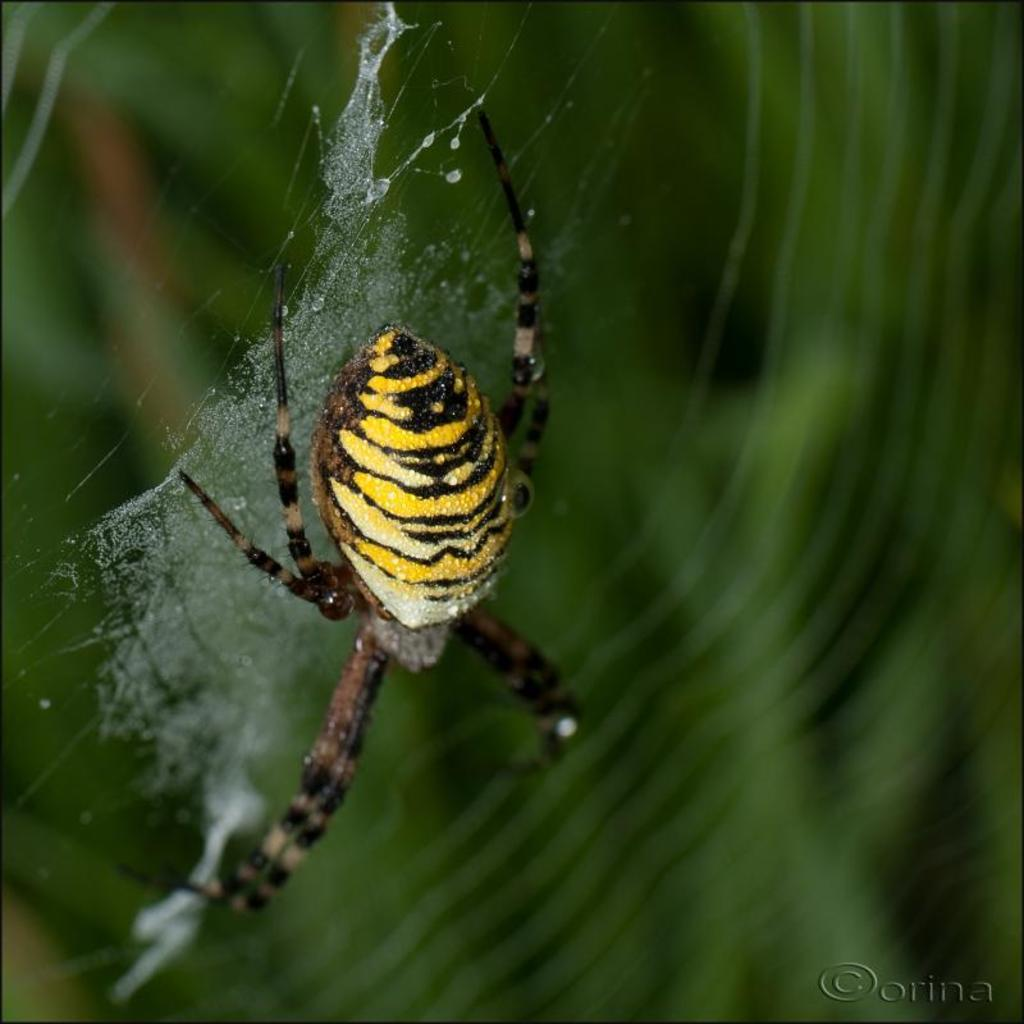What is the main subject of the image? There is a spider in the image. Can you describe the background of the image? The background of the image is blurred. What type of apparatus can be seen in the background of the image? There is no apparatus visible in the image; the background is blurred. Is there a playground in the image? There is no playground present in the image; it only features a spider. 